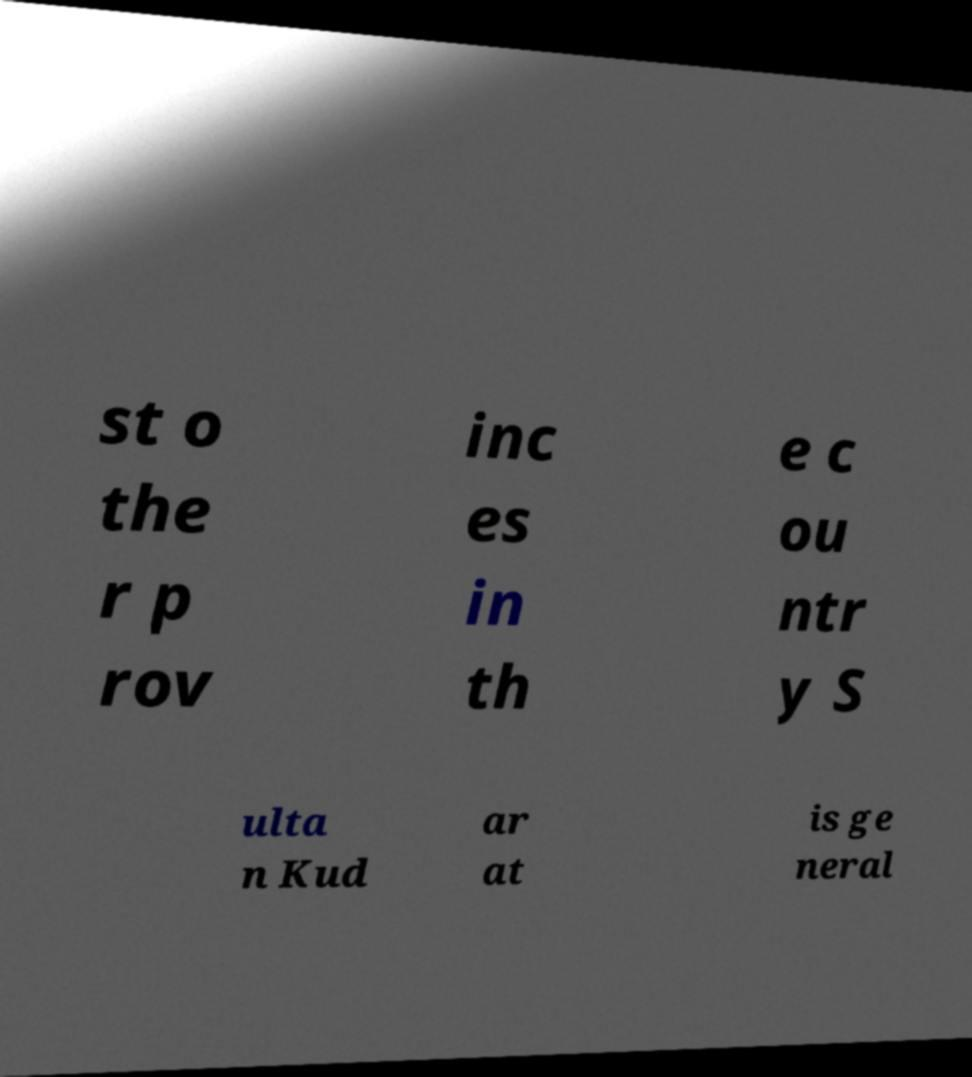Can you read and provide the text displayed in the image?This photo seems to have some interesting text. Can you extract and type it out for me? st o the r p rov inc es in th e c ou ntr y S ulta n Kud ar at is ge neral 